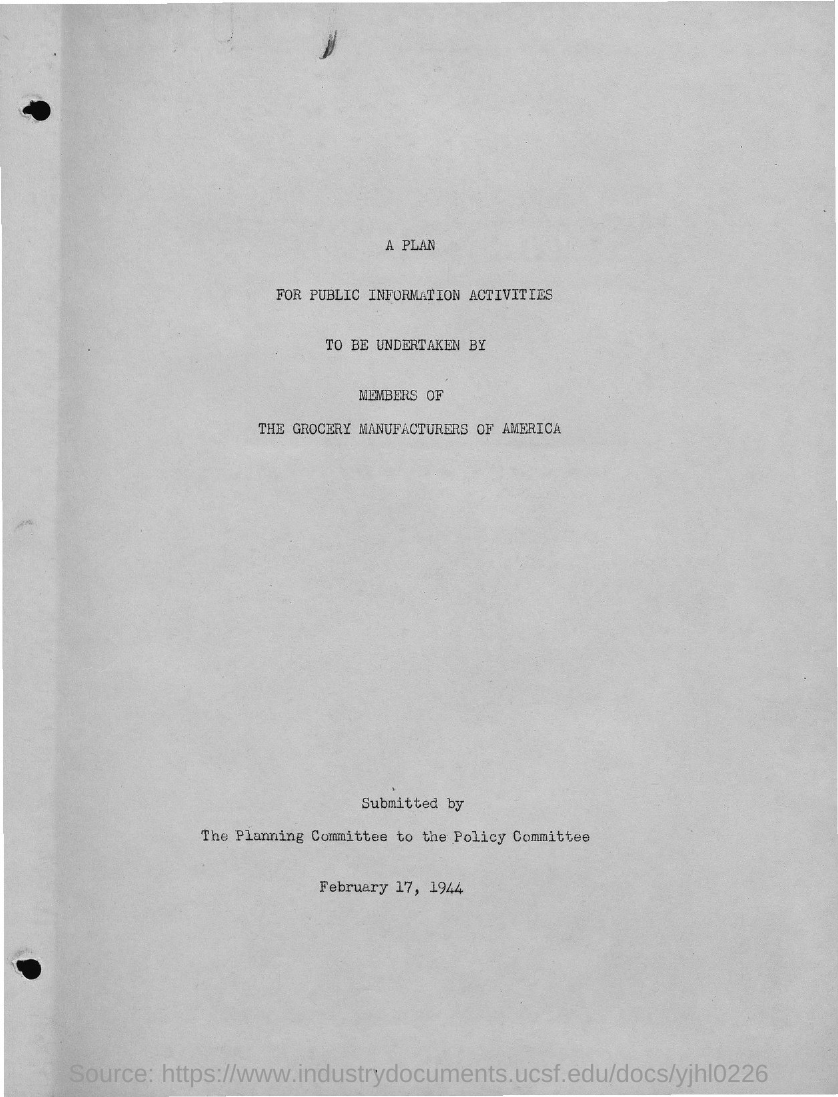List a handful of essential elements in this visual. The question of when the report was submitted is still unclear. The date provided, February 17, 1944, is insufficient to determine when the report was submitted. The planning committee submits the plan. It is the members of the Grocery Manufacturers of America who will be undertaking the plan. The title is 'A plan for public information activities.' 